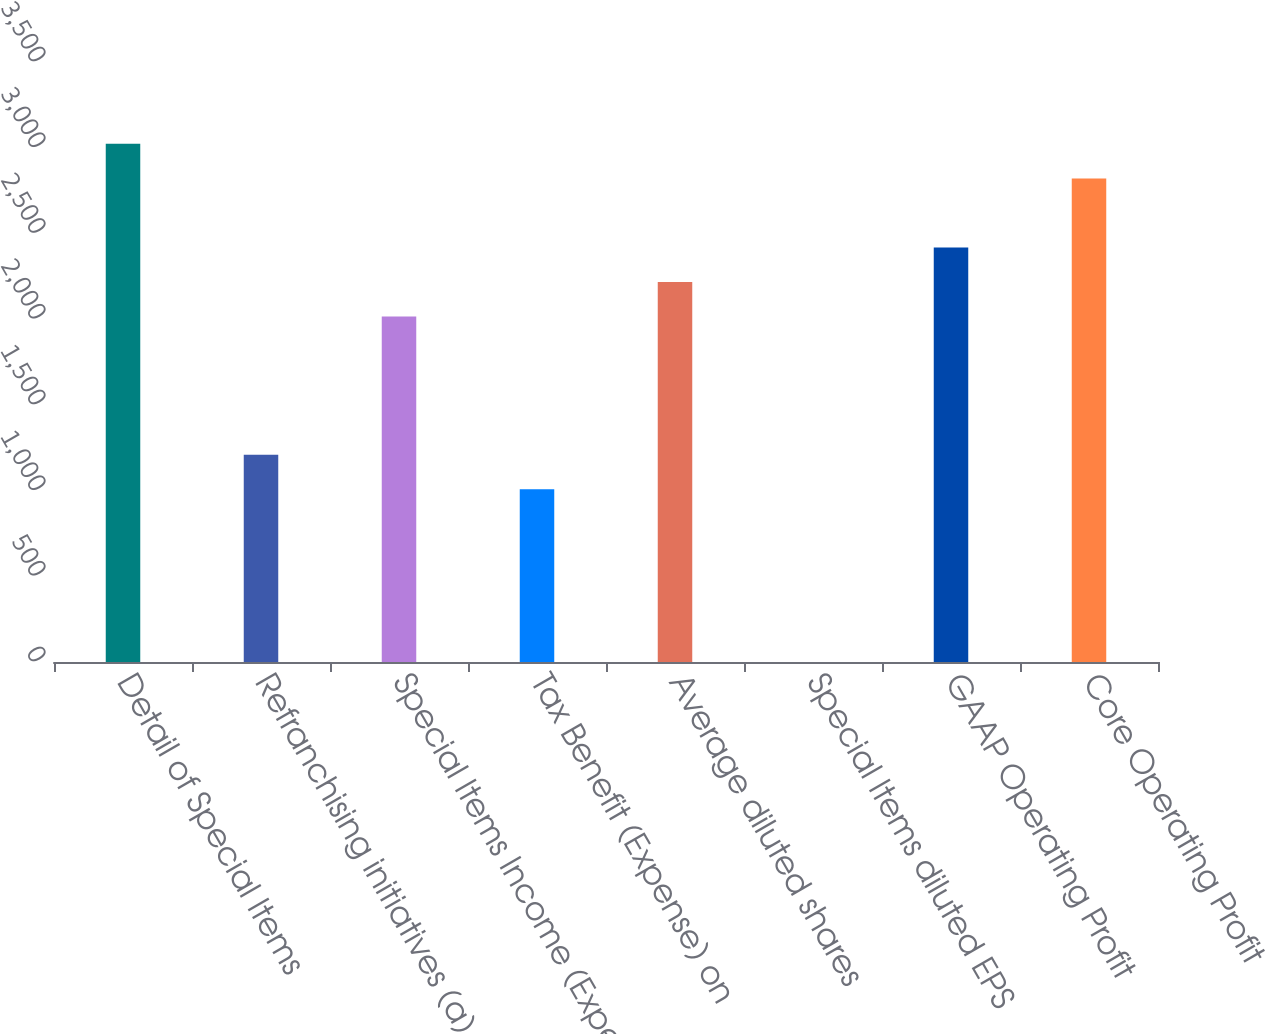Convert chart to OTSL. <chart><loc_0><loc_0><loc_500><loc_500><bar_chart><fcel>Detail of Special Items<fcel>Refranchising initiatives (a)<fcel>Special Items Income (Expense)<fcel>Tax Benefit (Expense) on<fcel>Average diluted shares<fcel>Special Items diluted EPS<fcel>GAAP Operating Profit<fcel>Core Operating Profit<nl><fcel>3022.42<fcel>1209.1<fcel>2015.02<fcel>1007.62<fcel>2216.5<fcel>0.22<fcel>2417.98<fcel>2820.94<nl></chart> 